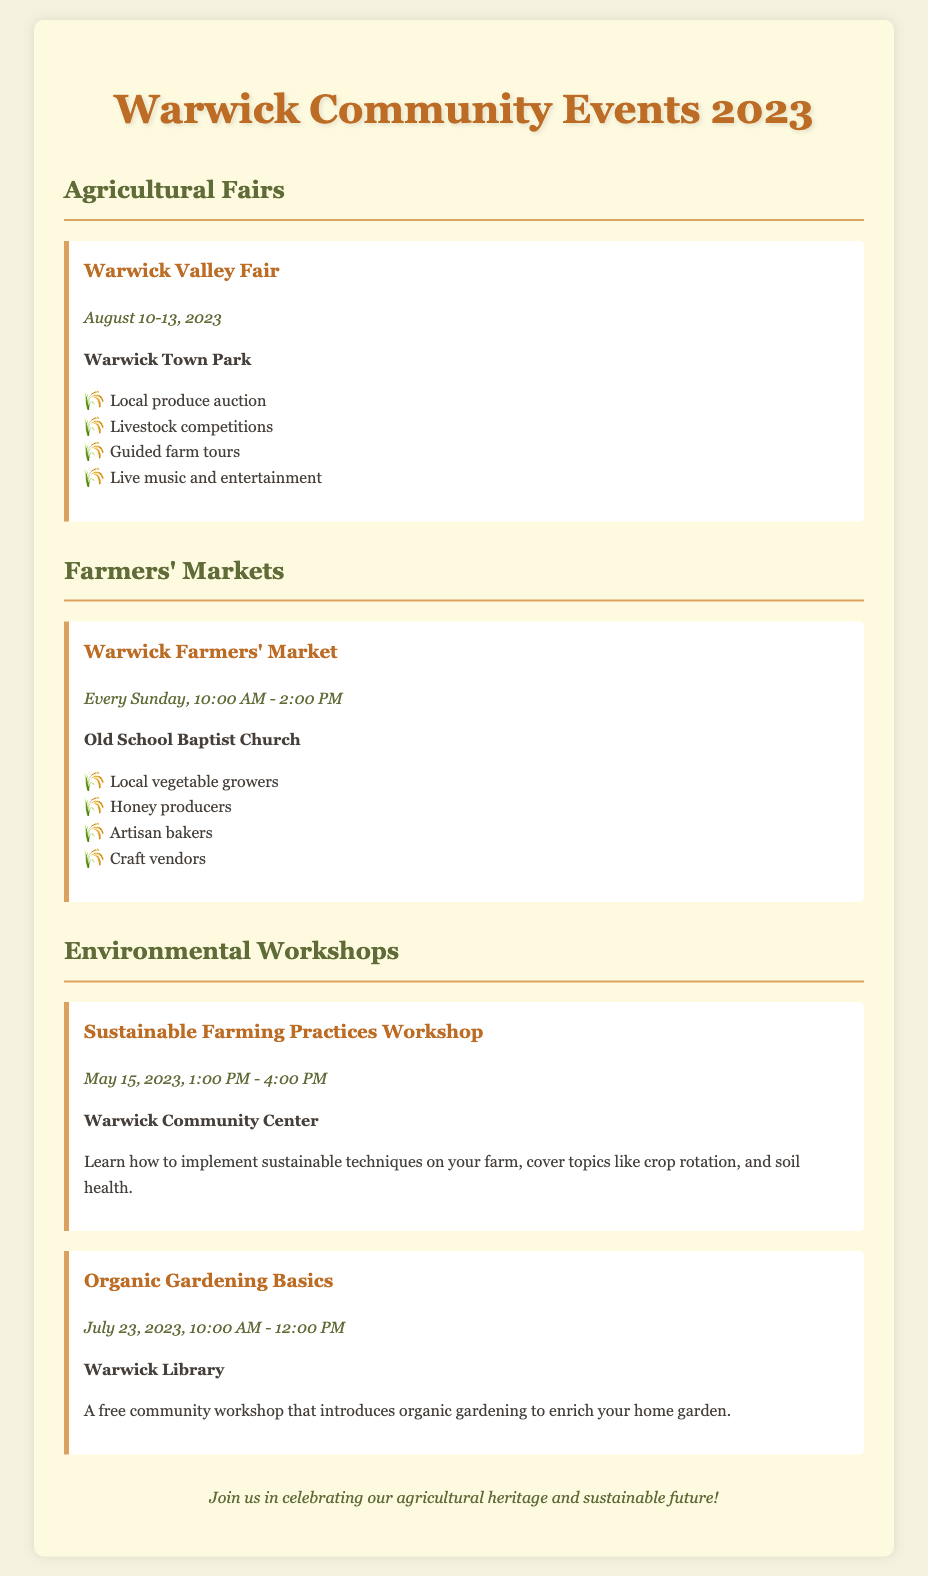What are the dates of the Warwick Valley Fair? The document lists the dates of the Warwick Valley Fair as August 10-13, 2023.
Answer: August 10-13, 2023 Where is the Warwick Farmers' Market held? The location of the Warwick Farmers' Market is specified as the Old School Baptist Church in the document.
Answer: Old School Baptist Church What time does the Warwick Farmers' Market open? The document states that the Warwick Farmers' Market operates every Sunday from 10:00 AM to 2:00 PM.
Answer: 10:00 AM What is one activity at the Warwick Valley Fair? The document lists several activities at the Warwick Valley Fair, including local produce auction, making it one of the activities mentioned.
Answer: Local produce auction How many environmental workshops are listed in the document? The document features two environmental workshops: Sustainable Farming Practices Workshop and Organic Gardening Basics.
Answer: Two When is the Organic Gardening Basics workshop? According to the document, the Organic Gardening Basics workshop occurs on July 23, 2023.
Answer: July 23, 2023 What venue hosts the Sustainable Farming Practices Workshop? The venue for the Sustainable Farming Practices Workshop is mentioned as the Warwick Community Center in the document.
Answer: Warwick Community Center What are the main themes covered in the Sustainable Farming Practices Workshop? The main themes include crop rotation and soil health, as stated in the document.
Answer: Crop rotation and soil health Who is encouraged to join the community events? The footer of the document encourages everyone to celebrate agricultural heritage and sustainable future.
Answer: Everyone 